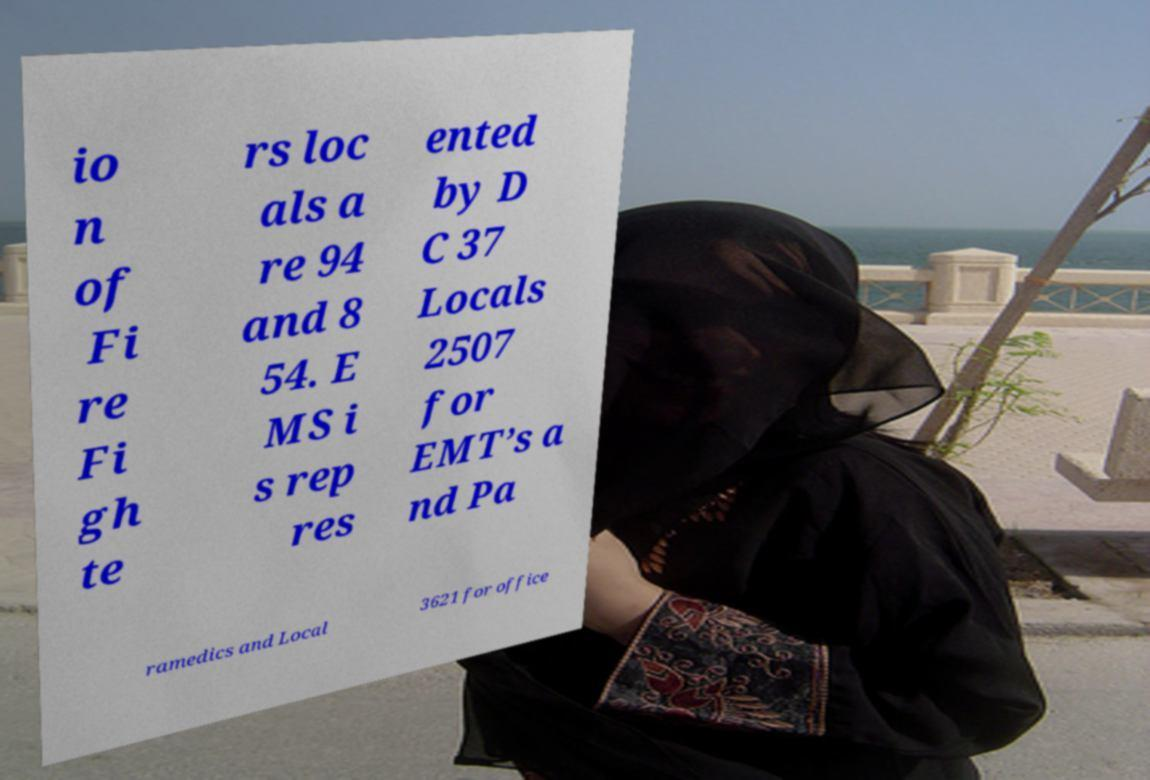Could you extract and type out the text from this image? io n of Fi re Fi gh te rs loc als a re 94 and 8 54. E MS i s rep res ented by D C 37 Locals 2507 for EMT’s a nd Pa ramedics and Local 3621 for office 